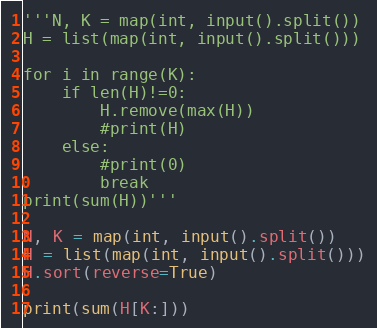Convert code to text. <code><loc_0><loc_0><loc_500><loc_500><_Python_>'''N, K = map(int, input().split())
H = list(map(int, input().split()))

for i in range(K):
    if len(H)!=0:
        H.remove(max(H))
        #print(H)
    else:
        #print(0)
        break
print(sum(H))'''

N, K = map(int, input().split())
H = list(map(int, input().split()))
H.sort(reverse=True)

print(sum(H[K:]))
</code> 